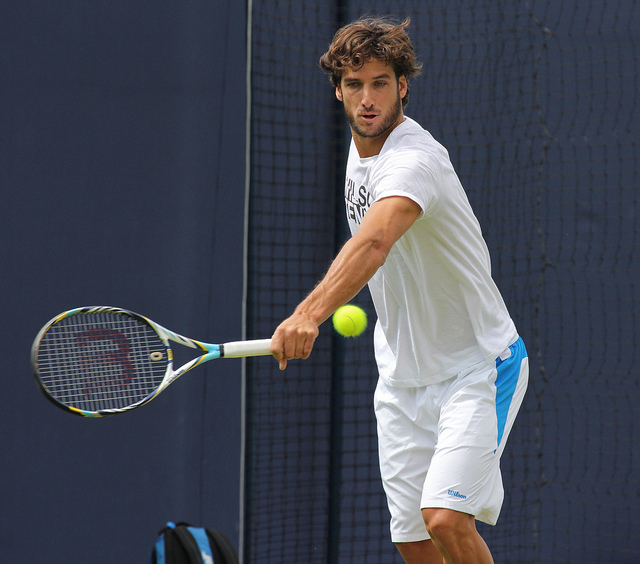Can you tell me what activity is being performed in the picture? The person in the image is playing tennis. He appears to be on a tennis court, in the middle of a forehand swing. What kind of equipment is necessary to play this sport? Tennis typically requires a racket, tennis balls, appropriate shoes for court surfaces, and comfortable athletic clothing. Players might also use accessories like sweatbands and a cap or visor. 